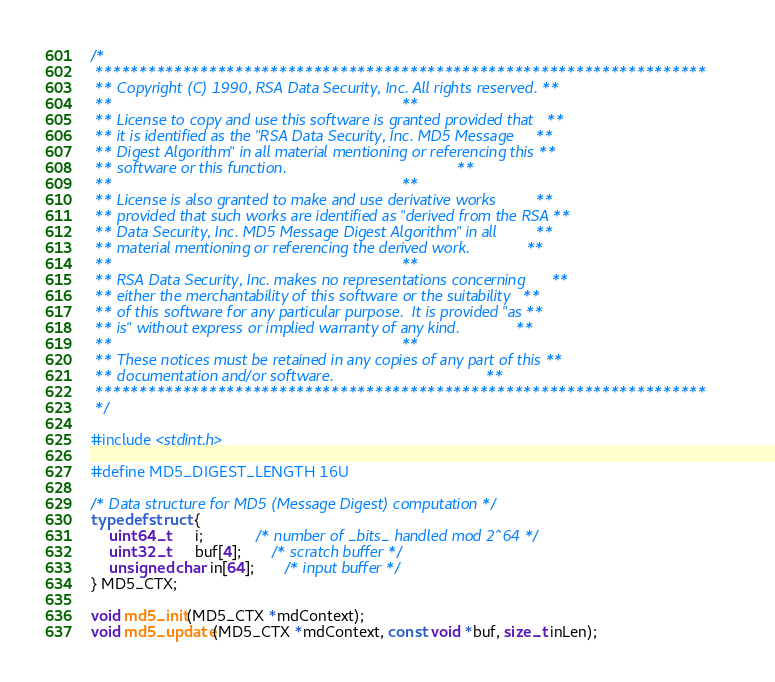<code> <loc_0><loc_0><loc_500><loc_500><_C_>/*
 **********************************************************************
 ** Copyright (C) 1990, RSA Data Security, Inc. All rights reserved. **
 **                                                                  **
 ** License to copy and use this software is granted provided that   **
 ** it is identified as the "RSA Data Security, Inc. MD5 Message     **
 ** Digest Algorithm" in all material mentioning or referencing this **
 ** software or this function.                                       **
 **                                                                  **
 ** License is also granted to make and use derivative works         **
 ** provided that such works are identified as "derived from the RSA **
 ** Data Security, Inc. MD5 Message Digest Algorithm" in all         **
 ** material mentioning or referencing the derived work.             **
 **                                                                  **
 ** RSA Data Security, Inc. makes no representations concerning      **
 ** either the merchantability of this software or the suitability   **
 ** of this software for any particular purpose.  It is provided "as **
 ** is" without express or implied warranty of any kind.             **
 **                                                                  **
 ** These notices must be retained in any copies of any part of this **
 ** documentation and/or software.                                   **
 **********************************************************************
 */

#include <stdint.h>

#define MD5_DIGEST_LENGTH 16U

/* Data structure for MD5 (Message Digest) computation */
typedef struct {
    uint64_t      i;            /* number of _bits_ handled mod 2^64 */
    uint32_t      buf[4];       /* scratch buffer */
    unsigned char in[64];       /* input buffer */
} MD5_CTX;

void md5_init(MD5_CTX *mdContext);
void md5_update(MD5_CTX *mdContext, const void *buf, size_t inLen);</code> 